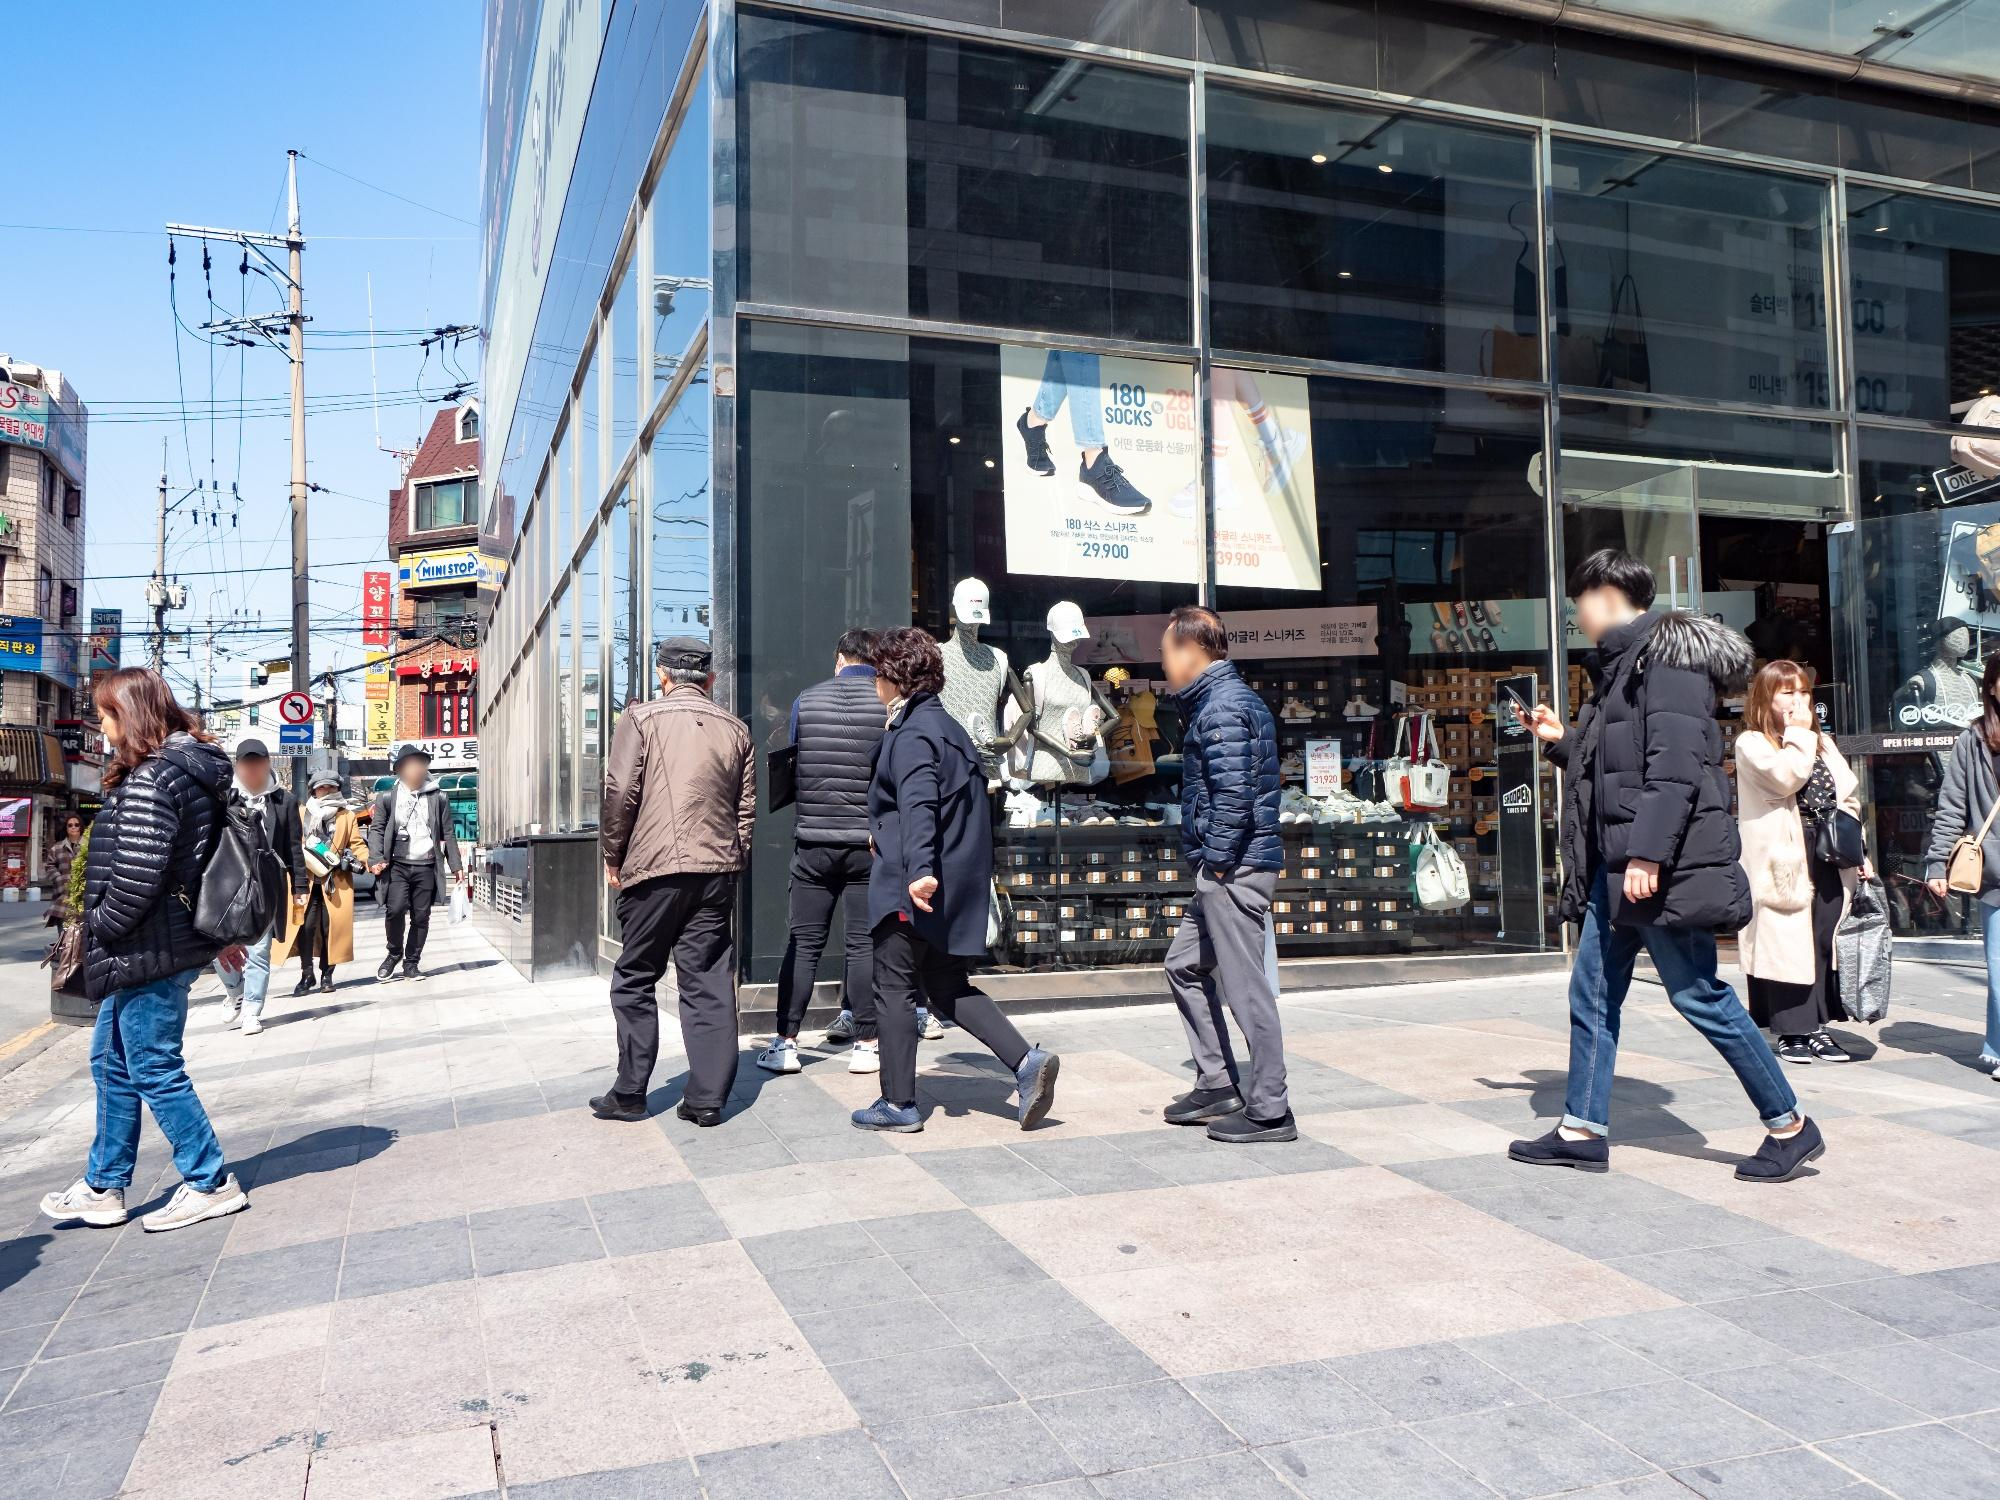What can you infer about the lifestyle of people based on their attire and activities in this image? From the image, it appears that the people captured are dressed in comfortable, yet stylish clothing suitable for city life. Many wear jackets and carry bags, suggesting readiness for a day of shopping or errands. Their attire ranges from casual to slightly formal, indicating that this area could serve multiple purposes, from leisurely outings to more formal engagements. The presence of both young and older adults in various groups or alone suggests this area is frequented by a diverse demographic, reflecting a multifaceted urban lifestyle. 